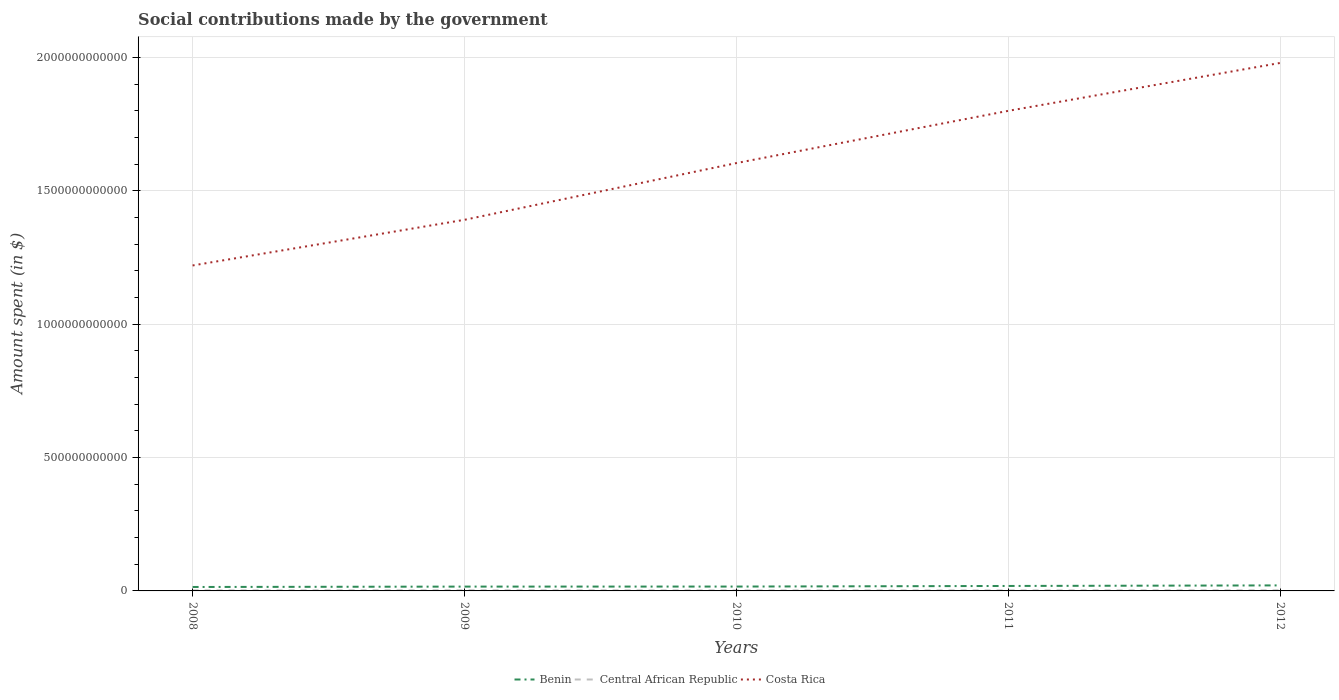How many different coloured lines are there?
Your answer should be very brief. 3. Does the line corresponding to Benin intersect with the line corresponding to Costa Rica?
Your answer should be very brief. No. Is the number of lines equal to the number of legend labels?
Give a very brief answer. Yes. Across all years, what is the maximum amount spent on social contributions in Central African Republic?
Offer a terse response. 1.82e+09. What is the total amount spent on social contributions in Costa Rica in the graph?
Your response must be concise. -3.84e+11. What is the difference between the highest and the second highest amount spent on social contributions in Central African Republic?
Offer a very short reply. 5.41e+08. How many lines are there?
Offer a very short reply. 3. How many years are there in the graph?
Your answer should be compact. 5. What is the difference between two consecutive major ticks on the Y-axis?
Keep it short and to the point. 5.00e+11. Are the values on the major ticks of Y-axis written in scientific E-notation?
Your answer should be compact. No. Does the graph contain any zero values?
Ensure brevity in your answer.  No. How many legend labels are there?
Provide a succinct answer. 3. What is the title of the graph?
Your answer should be very brief. Social contributions made by the government. Does "Togo" appear as one of the legend labels in the graph?
Offer a terse response. No. What is the label or title of the Y-axis?
Your answer should be compact. Amount spent (in $). What is the Amount spent (in $) in Benin in 2008?
Your response must be concise. 1.48e+1. What is the Amount spent (in $) in Central African Republic in 2008?
Your answer should be compact. 2.00e+09. What is the Amount spent (in $) of Costa Rica in 2008?
Your response must be concise. 1.22e+12. What is the Amount spent (in $) of Benin in 2009?
Give a very brief answer. 1.62e+1. What is the Amount spent (in $) of Central African Republic in 2009?
Your answer should be very brief. 2.37e+09. What is the Amount spent (in $) in Costa Rica in 2009?
Give a very brief answer. 1.39e+12. What is the Amount spent (in $) in Benin in 2010?
Your answer should be compact. 1.64e+1. What is the Amount spent (in $) of Central African Republic in 2010?
Offer a terse response. 1.82e+09. What is the Amount spent (in $) in Costa Rica in 2010?
Offer a terse response. 1.60e+12. What is the Amount spent (in $) in Benin in 2011?
Offer a terse response. 1.86e+1. What is the Amount spent (in $) of Central African Republic in 2011?
Offer a very short reply. 1.99e+09. What is the Amount spent (in $) in Costa Rica in 2011?
Your response must be concise. 1.80e+12. What is the Amount spent (in $) of Benin in 2012?
Provide a short and direct response. 2.07e+1. What is the Amount spent (in $) in Central African Republic in 2012?
Offer a very short reply. 2.20e+09. What is the Amount spent (in $) of Costa Rica in 2012?
Offer a terse response. 1.98e+12. Across all years, what is the maximum Amount spent (in $) in Benin?
Ensure brevity in your answer.  2.07e+1. Across all years, what is the maximum Amount spent (in $) of Central African Republic?
Provide a succinct answer. 2.37e+09. Across all years, what is the maximum Amount spent (in $) of Costa Rica?
Keep it short and to the point. 1.98e+12. Across all years, what is the minimum Amount spent (in $) in Benin?
Make the answer very short. 1.48e+1. Across all years, what is the minimum Amount spent (in $) of Central African Republic?
Give a very brief answer. 1.82e+09. Across all years, what is the minimum Amount spent (in $) in Costa Rica?
Offer a terse response. 1.22e+12. What is the total Amount spent (in $) of Benin in the graph?
Offer a very short reply. 8.67e+1. What is the total Amount spent (in $) of Central African Republic in the graph?
Your response must be concise. 1.04e+1. What is the total Amount spent (in $) in Costa Rica in the graph?
Make the answer very short. 8.00e+12. What is the difference between the Amount spent (in $) in Benin in 2008 and that in 2009?
Give a very brief answer. -1.43e+09. What is the difference between the Amount spent (in $) of Central African Republic in 2008 and that in 2009?
Make the answer very short. -3.65e+08. What is the difference between the Amount spent (in $) in Costa Rica in 2008 and that in 2009?
Keep it short and to the point. -1.71e+11. What is the difference between the Amount spent (in $) in Benin in 2008 and that in 2010?
Offer a terse response. -1.58e+09. What is the difference between the Amount spent (in $) of Central African Republic in 2008 and that in 2010?
Provide a short and direct response. 1.76e+08. What is the difference between the Amount spent (in $) in Costa Rica in 2008 and that in 2010?
Offer a very short reply. -3.84e+11. What is the difference between the Amount spent (in $) of Benin in 2008 and that in 2011?
Make the answer very short. -3.82e+09. What is the difference between the Amount spent (in $) of Central African Republic in 2008 and that in 2011?
Your response must be concise. 1.32e+07. What is the difference between the Amount spent (in $) in Costa Rica in 2008 and that in 2011?
Offer a terse response. -5.80e+11. What is the difference between the Amount spent (in $) of Benin in 2008 and that in 2012?
Your answer should be compact. -5.93e+09. What is the difference between the Amount spent (in $) in Central African Republic in 2008 and that in 2012?
Give a very brief answer. -1.96e+08. What is the difference between the Amount spent (in $) in Costa Rica in 2008 and that in 2012?
Provide a short and direct response. -7.60e+11. What is the difference between the Amount spent (in $) of Benin in 2009 and that in 2010?
Provide a short and direct response. -1.53e+08. What is the difference between the Amount spent (in $) of Central African Republic in 2009 and that in 2010?
Ensure brevity in your answer.  5.41e+08. What is the difference between the Amount spent (in $) of Costa Rica in 2009 and that in 2010?
Offer a very short reply. -2.13e+11. What is the difference between the Amount spent (in $) of Benin in 2009 and that in 2011?
Make the answer very short. -2.39e+09. What is the difference between the Amount spent (in $) in Central African Republic in 2009 and that in 2011?
Provide a succinct answer. 3.78e+08. What is the difference between the Amount spent (in $) of Costa Rica in 2009 and that in 2011?
Offer a very short reply. -4.09e+11. What is the difference between the Amount spent (in $) in Benin in 2009 and that in 2012?
Your response must be concise. -4.50e+09. What is the difference between the Amount spent (in $) of Central African Republic in 2009 and that in 2012?
Keep it short and to the point. 1.69e+08. What is the difference between the Amount spent (in $) of Costa Rica in 2009 and that in 2012?
Your answer should be compact. -5.88e+11. What is the difference between the Amount spent (in $) of Benin in 2010 and that in 2011?
Your answer should be compact. -2.24e+09. What is the difference between the Amount spent (in $) of Central African Republic in 2010 and that in 2011?
Give a very brief answer. -1.63e+08. What is the difference between the Amount spent (in $) of Costa Rica in 2010 and that in 2011?
Offer a very short reply. -1.96e+11. What is the difference between the Amount spent (in $) in Benin in 2010 and that in 2012?
Ensure brevity in your answer.  -4.35e+09. What is the difference between the Amount spent (in $) of Central African Republic in 2010 and that in 2012?
Your response must be concise. -3.72e+08. What is the difference between the Amount spent (in $) in Costa Rica in 2010 and that in 2012?
Give a very brief answer. -3.76e+11. What is the difference between the Amount spent (in $) in Benin in 2011 and that in 2012?
Make the answer very short. -2.12e+09. What is the difference between the Amount spent (in $) of Central African Republic in 2011 and that in 2012?
Keep it short and to the point. -2.09e+08. What is the difference between the Amount spent (in $) in Costa Rica in 2011 and that in 2012?
Provide a succinct answer. -1.80e+11. What is the difference between the Amount spent (in $) in Benin in 2008 and the Amount spent (in $) in Central African Republic in 2009?
Provide a short and direct response. 1.24e+1. What is the difference between the Amount spent (in $) in Benin in 2008 and the Amount spent (in $) in Costa Rica in 2009?
Make the answer very short. -1.38e+12. What is the difference between the Amount spent (in $) of Central African Republic in 2008 and the Amount spent (in $) of Costa Rica in 2009?
Provide a short and direct response. -1.39e+12. What is the difference between the Amount spent (in $) of Benin in 2008 and the Amount spent (in $) of Central African Republic in 2010?
Your answer should be compact. 1.30e+1. What is the difference between the Amount spent (in $) in Benin in 2008 and the Amount spent (in $) in Costa Rica in 2010?
Your answer should be compact. -1.59e+12. What is the difference between the Amount spent (in $) of Central African Republic in 2008 and the Amount spent (in $) of Costa Rica in 2010?
Provide a short and direct response. -1.60e+12. What is the difference between the Amount spent (in $) of Benin in 2008 and the Amount spent (in $) of Central African Republic in 2011?
Provide a succinct answer. 1.28e+1. What is the difference between the Amount spent (in $) of Benin in 2008 and the Amount spent (in $) of Costa Rica in 2011?
Offer a very short reply. -1.79e+12. What is the difference between the Amount spent (in $) in Central African Republic in 2008 and the Amount spent (in $) in Costa Rica in 2011?
Give a very brief answer. -1.80e+12. What is the difference between the Amount spent (in $) of Benin in 2008 and the Amount spent (in $) of Central African Republic in 2012?
Your answer should be compact. 1.26e+1. What is the difference between the Amount spent (in $) in Benin in 2008 and the Amount spent (in $) in Costa Rica in 2012?
Make the answer very short. -1.97e+12. What is the difference between the Amount spent (in $) of Central African Republic in 2008 and the Amount spent (in $) of Costa Rica in 2012?
Offer a very short reply. -1.98e+12. What is the difference between the Amount spent (in $) in Benin in 2009 and the Amount spent (in $) in Central African Republic in 2010?
Keep it short and to the point. 1.44e+1. What is the difference between the Amount spent (in $) in Benin in 2009 and the Amount spent (in $) in Costa Rica in 2010?
Your response must be concise. -1.59e+12. What is the difference between the Amount spent (in $) of Central African Republic in 2009 and the Amount spent (in $) of Costa Rica in 2010?
Give a very brief answer. -1.60e+12. What is the difference between the Amount spent (in $) of Benin in 2009 and the Amount spent (in $) of Central African Republic in 2011?
Your answer should be very brief. 1.42e+1. What is the difference between the Amount spent (in $) in Benin in 2009 and the Amount spent (in $) in Costa Rica in 2011?
Offer a terse response. -1.78e+12. What is the difference between the Amount spent (in $) in Central African Republic in 2009 and the Amount spent (in $) in Costa Rica in 2011?
Offer a terse response. -1.80e+12. What is the difference between the Amount spent (in $) in Benin in 2009 and the Amount spent (in $) in Central African Republic in 2012?
Provide a short and direct response. 1.40e+1. What is the difference between the Amount spent (in $) of Benin in 2009 and the Amount spent (in $) of Costa Rica in 2012?
Offer a very short reply. -1.96e+12. What is the difference between the Amount spent (in $) of Central African Republic in 2009 and the Amount spent (in $) of Costa Rica in 2012?
Your response must be concise. -1.98e+12. What is the difference between the Amount spent (in $) of Benin in 2010 and the Amount spent (in $) of Central African Republic in 2011?
Your response must be concise. 1.44e+1. What is the difference between the Amount spent (in $) of Benin in 2010 and the Amount spent (in $) of Costa Rica in 2011?
Offer a terse response. -1.78e+12. What is the difference between the Amount spent (in $) of Central African Republic in 2010 and the Amount spent (in $) of Costa Rica in 2011?
Ensure brevity in your answer.  -1.80e+12. What is the difference between the Amount spent (in $) in Benin in 2010 and the Amount spent (in $) in Central African Republic in 2012?
Keep it short and to the point. 1.42e+1. What is the difference between the Amount spent (in $) in Benin in 2010 and the Amount spent (in $) in Costa Rica in 2012?
Provide a succinct answer. -1.96e+12. What is the difference between the Amount spent (in $) of Central African Republic in 2010 and the Amount spent (in $) of Costa Rica in 2012?
Give a very brief answer. -1.98e+12. What is the difference between the Amount spent (in $) in Benin in 2011 and the Amount spent (in $) in Central African Republic in 2012?
Give a very brief answer. 1.64e+1. What is the difference between the Amount spent (in $) in Benin in 2011 and the Amount spent (in $) in Costa Rica in 2012?
Provide a succinct answer. -1.96e+12. What is the difference between the Amount spent (in $) of Central African Republic in 2011 and the Amount spent (in $) of Costa Rica in 2012?
Keep it short and to the point. -1.98e+12. What is the average Amount spent (in $) in Benin per year?
Provide a short and direct response. 1.73e+1. What is the average Amount spent (in $) of Central African Republic per year?
Keep it short and to the point. 2.08e+09. What is the average Amount spent (in $) of Costa Rica per year?
Keep it short and to the point. 1.60e+12. In the year 2008, what is the difference between the Amount spent (in $) of Benin and Amount spent (in $) of Central African Republic?
Your response must be concise. 1.28e+1. In the year 2008, what is the difference between the Amount spent (in $) of Benin and Amount spent (in $) of Costa Rica?
Your answer should be very brief. -1.21e+12. In the year 2008, what is the difference between the Amount spent (in $) of Central African Republic and Amount spent (in $) of Costa Rica?
Keep it short and to the point. -1.22e+12. In the year 2009, what is the difference between the Amount spent (in $) of Benin and Amount spent (in $) of Central African Republic?
Your answer should be compact. 1.38e+1. In the year 2009, what is the difference between the Amount spent (in $) in Benin and Amount spent (in $) in Costa Rica?
Give a very brief answer. -1.38e+12. In the year 2009, what is the difference between the Amount spent (in $) in Central African Republic and Amount spent (in $) in Costa Rica?
Your answer should be very brief. -1.39e+12. In the year 2010, what is the difference between the Amount spent (in $) in Benin and Amount spent (in $) in Central African Republic?
Ensure brevity in your answer.  1.45e+1. In the year 2010, what is the difference between the Amount spent (in $) in Benin and Amount spent (in $) in Costa Rica?
Provide a succinct answer. -1.59e+12. In the year 2010, what is the difference between the Amount spent (in $) of Central African Republic and Amount spent (in $) of Costa Rica?
Your answer should be compact. -1.60e+12. In the year 2011, what is the difference between the Amount spent (in $) of Benin and Amount spent (in $) of Central African Republic?
Keep it short and to the point. 1.66e+1. In the year 2011, what is the difference between the Amount spent (in $) of Benin and Amount spent (in $) of Costa Rica?
Your response must be concise. -1.78e+12. In the year 2011, what is the difference between the Amount spent (in $) in Central African Republic and Amount spent (in $) in Costa Rica?
Keep it short and to the point. -1.80e+12. In the year 2012, what is the difference between the Amount spent (in $) of Benin and Amount spent (in $) of Central African Republic?
Your response must be concise. 1.85e+1. In the year 2012, what is the difference between the Amount spent (in $) in Benin and Amount spent (in $) in Costa Rica?
Provide a succinct answer. -1.96e+12. In the year 2012, what is the difference between the Amount spent (in $) of Central African Republic and Amount spent (in $) of Costa Rica?
Ensure brevity in your answer.  -1.98e+12. What is the ratio of the Amount spent (in $) of Benin in 2008 to that in 2009?
Your answer should be compact. 0.91. What is the ratio of the Amount spent (in $) in Central African Republic in 2008 to that in 2009?
Provide a succinct answer. 0.85. What is the ratio of the Amount spent (in $) of Costa Rica in 2008 to that in 2009?
Keep it short and to the point. 0.88. What is the ratio of the Amount spent (in $) of Benin in 2008 to that in 2010?
Give a very brief answer. 0.9. What is the ratio of the Amount spent (in $) of Central African Republic in 2008 to that in 2010?
Give a very brief answer. 1.1. What is the ratio of the Amount spent (in $) of Costa Rica in 2008 to that in 2010?
Your answer should be very brief. 0.76. What is the ratio of the Amount spent (in $) in Benin in 2008 to that in 2011?
Offer a very short reply. 0.79. What is the ratio of the Amount spent (in $) of Costa Rica in 2008 to that in 2011?
Provide a succinct answer. 0.68. What is the ratio of the Amount spent (in $) of Benin in 2008 to that in 2012?
Give a very brief answer. 0.71. What is the ratio of the Amount spent (in $) in Central African Republic in 2008 to that in 2012?
Ensure brevity in your answer.  0.91. What is the ratio of the Amount spent (in $) of Costa Rica in 2008 to that in 2012?
Your answer should be compact. 0.62. What is the ratio of the Amount spent (in $) of Benin in 2009 to that in 2010?
Provide a short and direct response. 0.99. What is the ratio of the Amount spent (in $) in Central African Republic in 2009 to that in 2010?
Offer a terse response. 1.3. What is the ratio of the Amount spent (in $) in Costa Rica in 2009 to that in 2010?
Your answer should be compact. 0.87. What is the ratio of the Amount spent (in $) of Benin in 2009 to that in 2011?
Your response must be concise. 0.87. What is the ratio of the Amount spent (in $) of Central African Republic in 2009 to that in 2011?
Make the answer very short. 1.19. What is the ratio of the Amount spent (in $) in Costa Rica in 2009 to that in 2011?
Provide a short and direct response. 0.77. What is the ratio of the Amount spent (in $) in Benin in 2009 to that in 2012?
Provide a short and direct response. 0.78. What is the ratio of the Amount spent (in $) in Central African Republic in 2009 to that in 2012?
Offer a very short reply. 1.08. What is the ratio of the Amount spent (in $) in Costa Rica in 2009 to that in 2012?
Make the answer very short. 0.7. What is the ratio of the Amount spent (in $) in Benin in 2010 to that in 2011?
Your answer should be compact. 0.88. What is the ratio of the Amount spent (in $) in Central African Republic in 2010 to that in 2011?
Ensure brevity in your answer.  0.92. What is the ratio of the Amount spent (in $) in Costa Rica in 2010 to that in 2011?
Make the answer very short. 0.89. What is the ratio of the Amount spent (in $) in Benin in 2010 to that in 2012?
Give a very brief answer. 0.79. What is the ratio of the Amount spent (in $) in Central African Republic in 2010 to that in 2012?
Give a very brief answer. 0.83. What is the ratio of the Amount spent (in $) in Costa Rica in 2010 to that in 2012?
Your response must be concise. 0.81. What is the ratio of the Amount spent (in $) of Benin in 2011 to that in 2012?
Your response must be concise. 0.9. What is the ratio of the Amount spent (in $) of Central African Republic in 2011 to that in 2012?
Keep it short and to the point. 0.9. What is the ratio of the Amount spent (in $) in Costa Rica in 2011 to that in 2012?
Provide a succinct answer. 0.91. What is the difference between the highest and the second highest Amount spent (in $) of Benin?
Give a very brief answer. 2.12e+09. What is the difference between the highest and the second highest Amount spent (in $) in Central African Republic?
Give a very brief answer. 1.69e+08. What is the difference between the highest and the second highest Amount spent (in $) of Costa Rica?
Provide a short and direct response. 1.80e+11. What is the difference between the highest and the lowest Amount spent (in $) of Benin?
Provide a short and direct response. 5.93e+09. What is the difference between the highest and the lowest Amount spent (in $) in Central African Republic?
Offer a terse response. 5.41e+08. What is the difference between the highest and the lowest Amount spent (in $) of Costa Rica?
Offer a very short reply. 7.60e+11. 